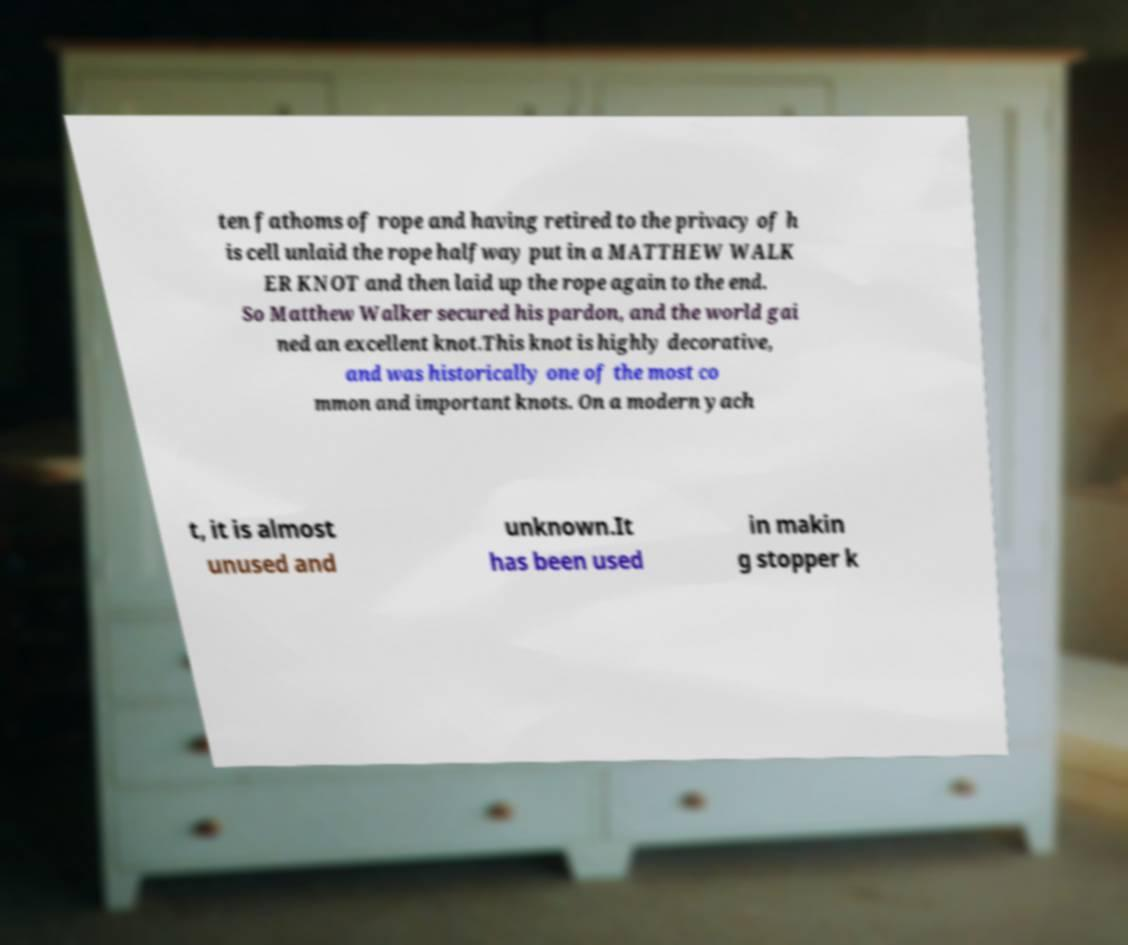Can you accurately transcribe the text from the provided image for me? ten fathoms of rope and having retired to the privacy of h is cell unlaid the rope halfway put in a MATTHEW WALK ER KNOT and then laid up the rope again to the end. So Matthew Walker secured his pardon, and the world gai ned an excellent knot.This knot is highly decorative, and was historically one of the most co mmon and important knots. On a modern yach t, it is almost unused and unknown.It has been used in makin g stopper k 